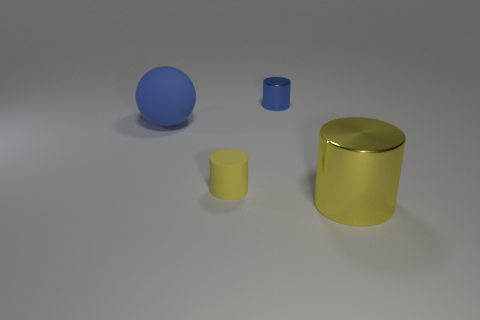Add 4 big green objects. How many objects exist? 8 Subtract all spheres. How many objects are left? 3 Add 2 tiny metal cylinders. How many tiny metal cylinders are left? 3 Add 2 yellow rubber things. How many yellow rubber things exist? 3 Subtract 0 gray cubes. How many objects are left? 4 Subtract all big cyan rubber things. Subtract all cylinders. How many objects are left? 1 